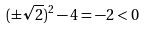Convert formula to latex. <formula><loc_0><loc_0><loc_500><loc_500>( \pm \sqrt { 2 } ) ^ { 2 } - 4 = - 2 < 0</formula> 